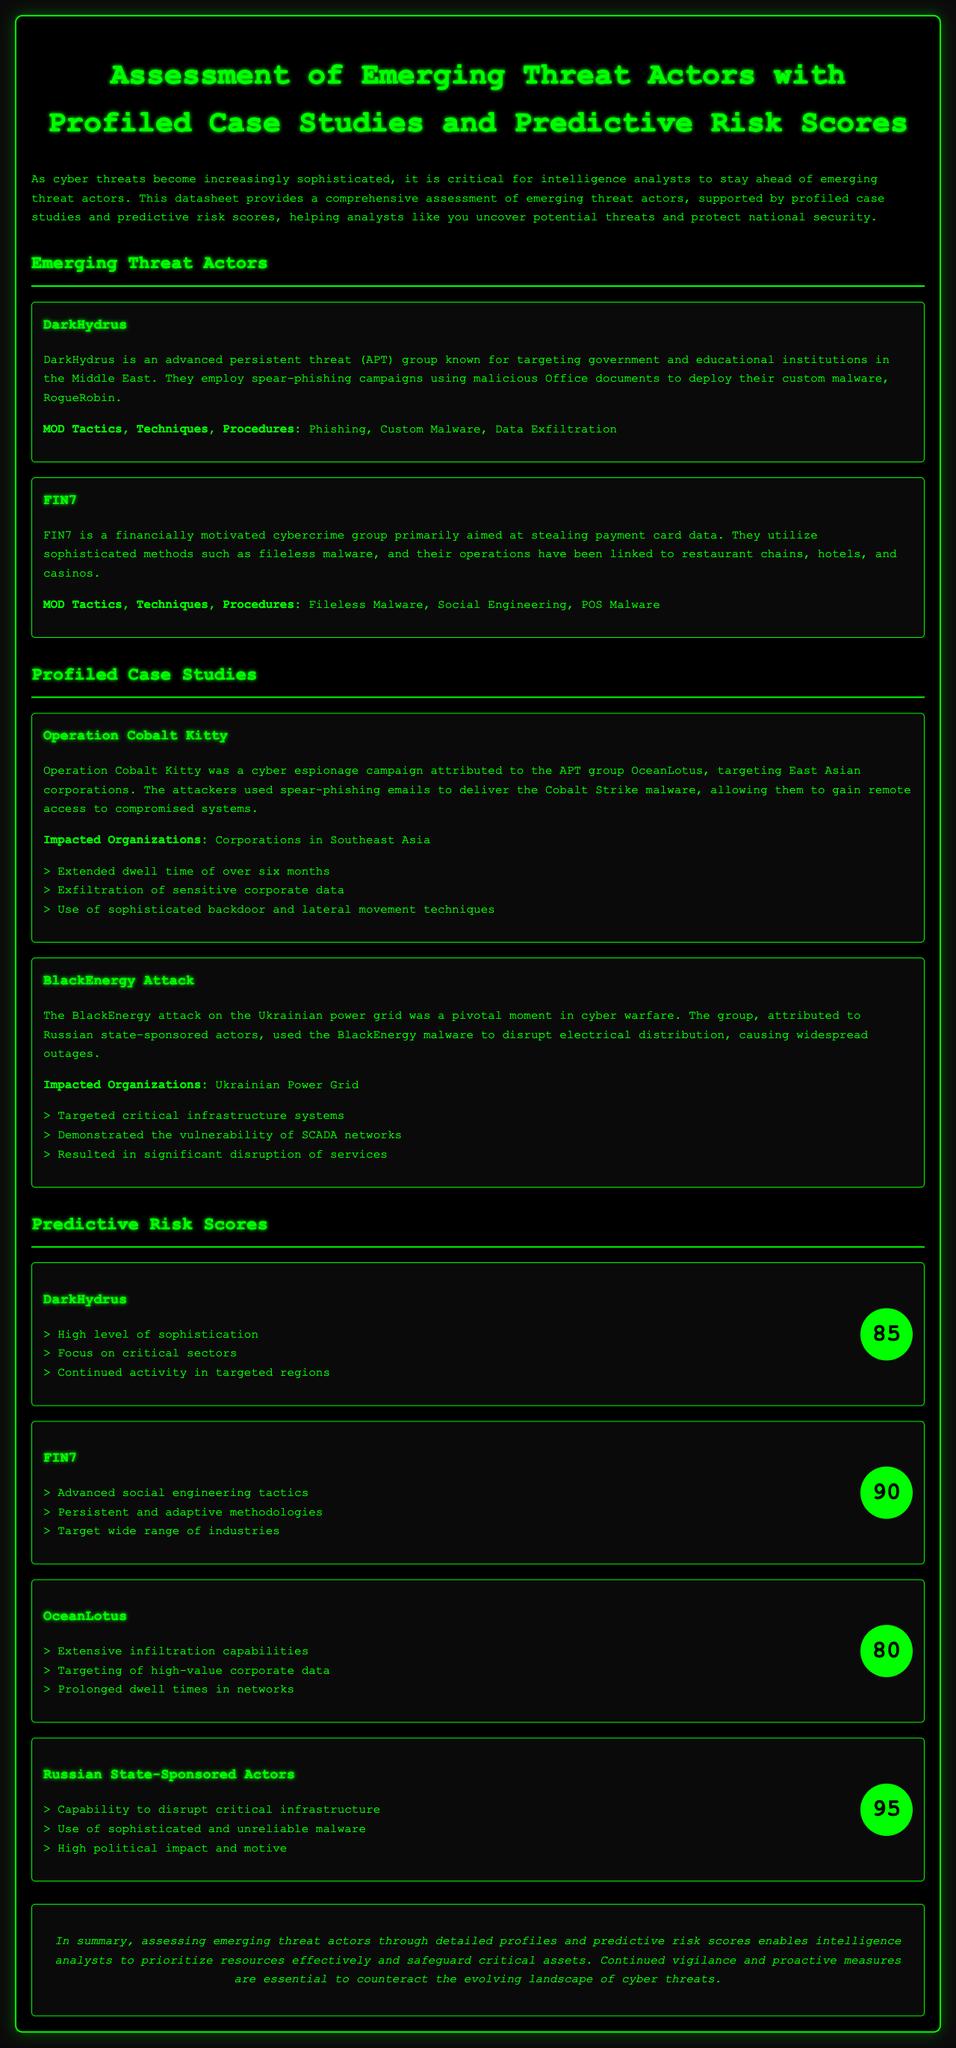What is the name of the APT group known for targeting government institutions? The document identifies DarkHydrus as an APT group known for targeting government institutions.
Answer: DarkHydrus Which malware is associated with DarkHydrus? The document states that DarkHydrus deploys the custom malware named RogueRobin.
Answer: RogueRobin What is the risk score for FIN7? The document lists the predictive risk score for FIN7 as 90.
Answer: 90 What type of attack was Operation Cobalt Kitty? The document classifies Operation Cobalt Kitty as a cyber espionage campaign.
Answer: cyber espionage What sector does FIN7 primarily target? The document mentions that FIN7 is primarily aimed at stealing payment card data in various sectors, particularly hospitality.
Answer: hospitality How long was the dwell time in Operation Cobalt Kitty? The dwell time mentioned in the document for Operation Cobalt Kitty was over six months.
Answer: over six months Which threat actor has the highest risk score? The document indicates that Russian state-sponsored actors have the highest risk score of 95.
Answer: 95 What malware was used in the BlackEnergy attack? The BlackEnergy attack employed the BlackEnergy malware as stated in the document.
Answer: BlackEnergy What is the affiliation of the group responsible for the BlackEnergy attack? The document attributes the BlackEnergy attack to Russian state-sponsored actors.
Answer: Russian state-sponsored actors 